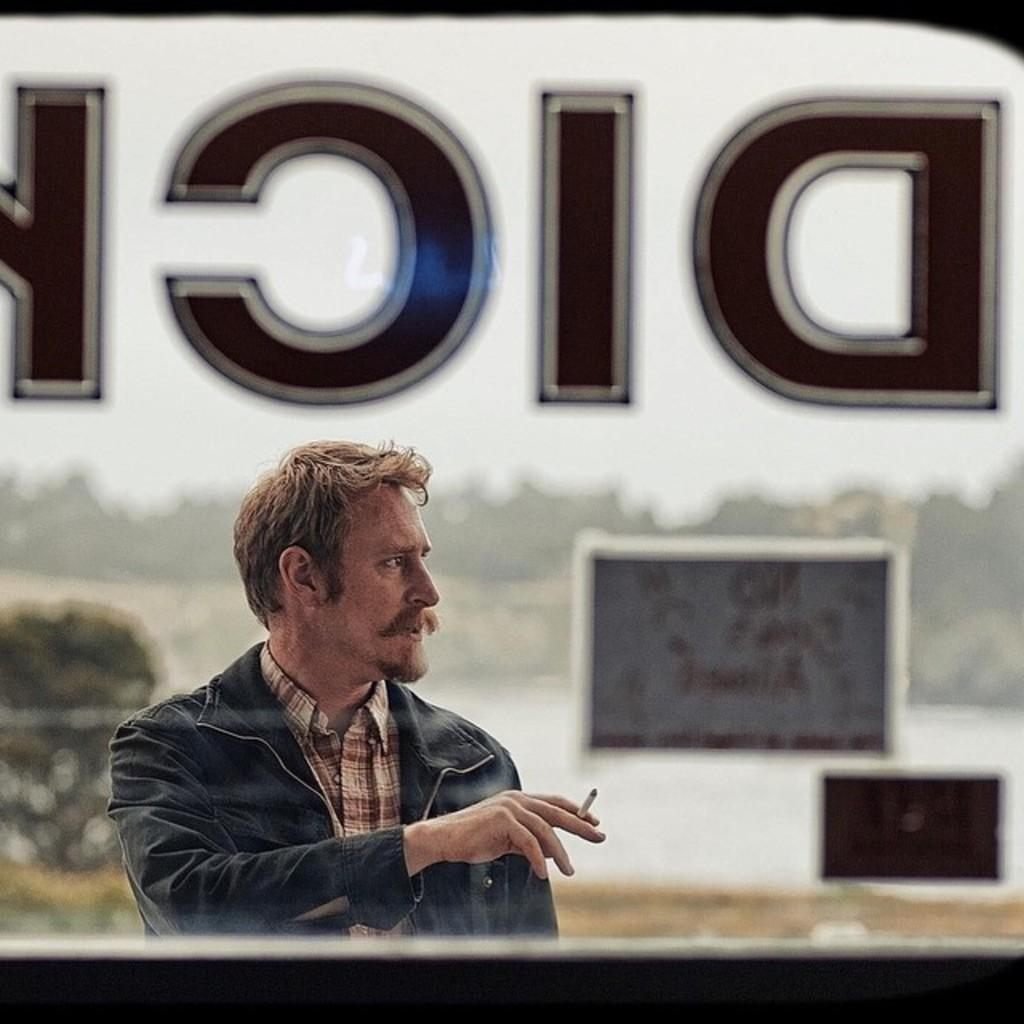What is the main subject of the image? There is a man in the image. What is the man holding in his hand? The man is holding a cigarette in his hand. What type of clothing is the man wearing? The man is wearing a coat and a shirt. What can be seen in the background of the image? There is a glass window in the image. What game is the man playing in the image? There is no game being played in the image; the man is simply holding a cigarette and wearing a coat and a shirt. 